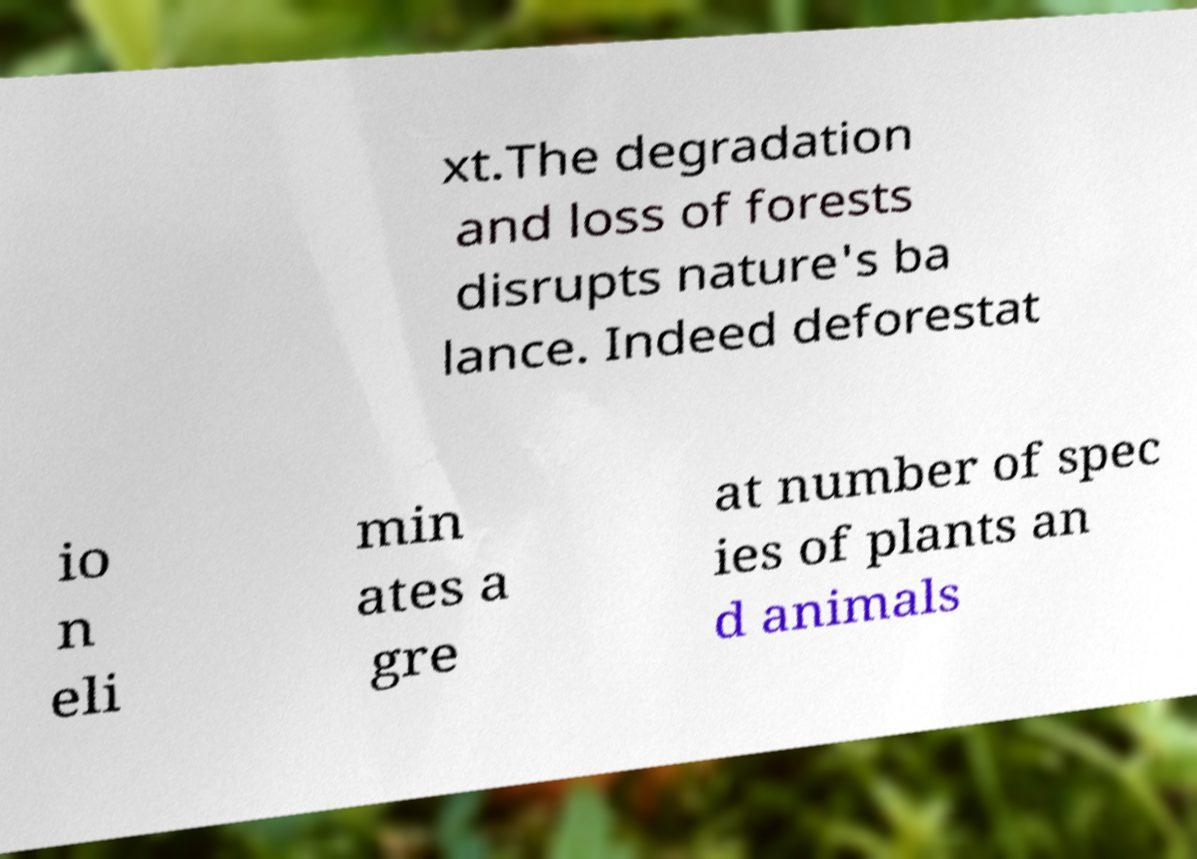Can you read and provide the text displayed in the image?This photo seems to have some interesting text. Can you extract and type it out for me? xt.The degradation and loss of forests disrupts nature's ba lance. Indeed deforestat io n eli min ates a gre at number of spec ies of plants an d animals 